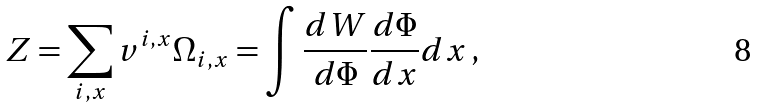<formula> <loc_0><loc_0><loc_500><loc_500>Z = \sum _ { i , x } v ^ { i , x } \Omega _ { i , x } = \int \frac { d W } { d \Phi } \frac { d \Phi } { d x } d x \, ,</formula> 